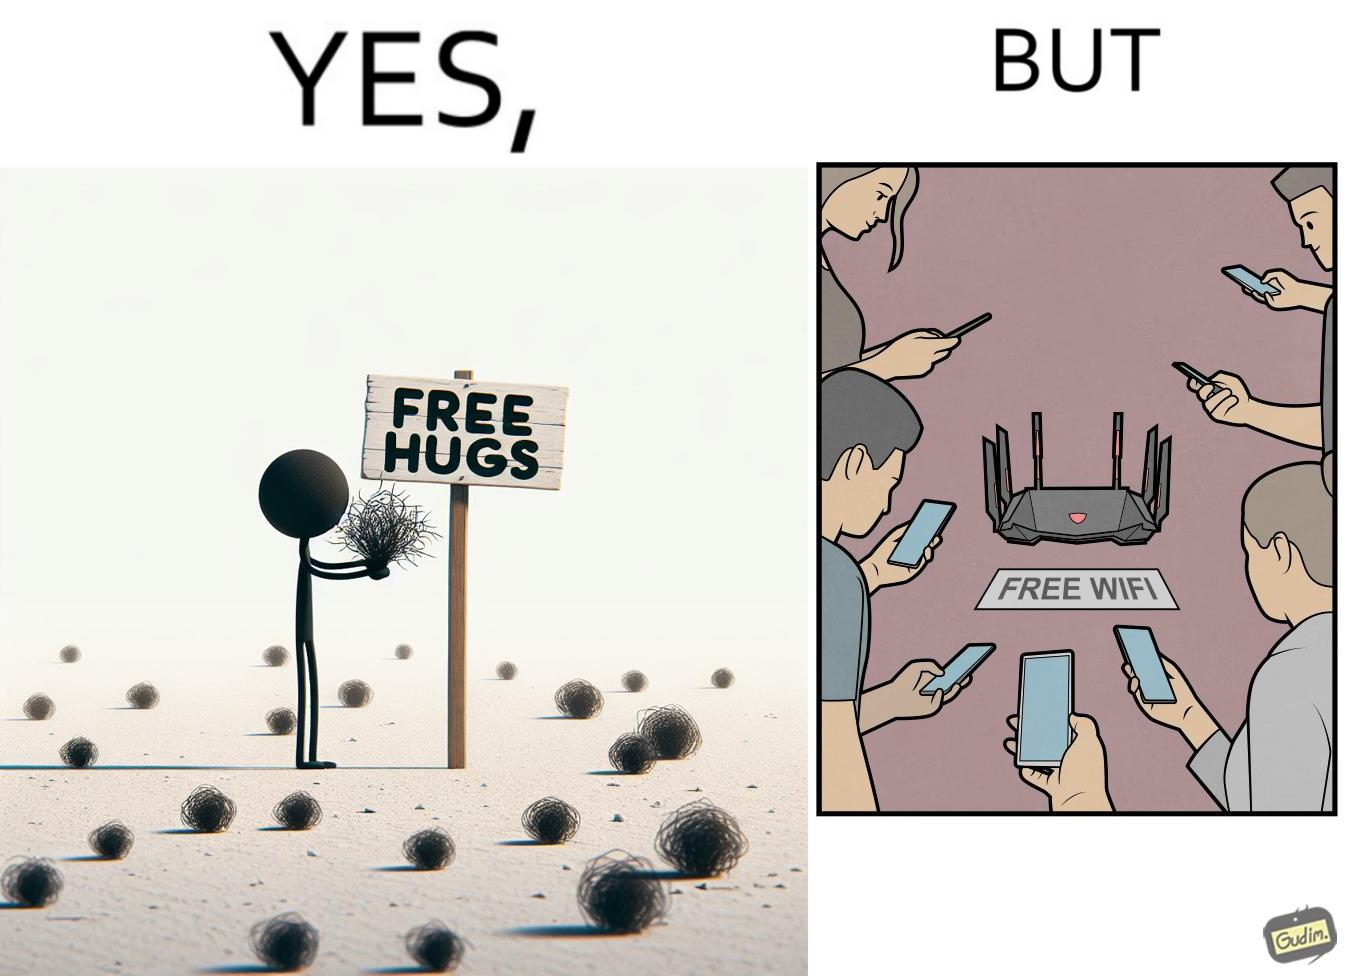What is the satirical meaning behind this image? This image is ironical, as a person holding up a "Free Hugs" sign is standing alone, while an inanimate Wi-fi Router giving "Free Wifi" is surrounded people trying to connect to it. This shows a growing lack of empathy in our society, while showing our increasing dependence on the digital devices in a virtual world. 